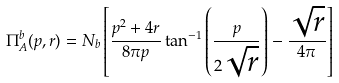<formula> <loc_0><loc_0><loc_500><loc_500>\Pi ^ { b } _ { A } ( p , r ) = N _ { b } \left [ \frac { p ^ { 2 } + 4 r } { 8 \pi p } \tan ^ { - 1 } \left ( \frac { p } { 2 \sqrt { r } } \right ) - \frac { \sqrt { r } } { 4 \pi } \right ]</formula> 